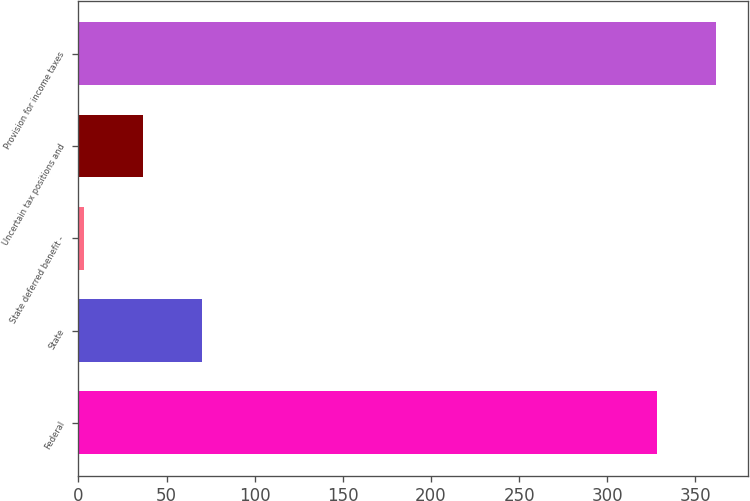Convert chart to OTSL. <chart><loc_0><loc_0><loc_500><loc_500><bar_chart><fcel>Federal<fcel>State<fcel>State deferred benefit -<fcel>Uncertain tax positions and<fcel>Provision for income taxes<nl><fcel>328.1<fcel>70.04<fcel>3.2<fcel>36.62<fcel>361.52<nl></chart> 